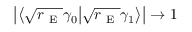Convert formula to latex. <formula><loc_0><loc_0><loc_500><loc_500>\left | \left \langle \sqrt { r _ { E } } \gamma _ { 0 } \Big | \sqrt { r _ { E } } \gamma _ { 1 } \right \rangle \right | \to 1</formula> 